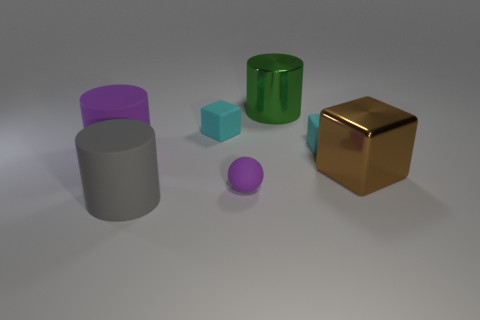Is there anything else that has the same shape as the small purple object?
Make the answer very short. No. The cyan object that is to the right of the tiny cyan rubber object that is on the left side of the purple ball is what shape?
Your response must be concise. Cube. There is a big block that is the same material as the green thing; what is its color?
Give a very brief answer. Brown. Is the large metal block the same color as the matte sphere?
Make the answer very short. No. The gray matte thing that is the same size as the brown object is what shape?
Ensure brevity in your answer.  Cylinder. What is the size of the purple rubber sphere?
Offer a very short reply. Small. Is the size of the cyan block on the left side of the purple ball the same as the cylinder left of the large gray matte cylinder?
Make the answer very short. No. There is a metal thing that is on the right side of the matte thing right of the matte sphere; what is its color?
Your answer should be very brief. Brown. What is the material of the cube that is the same size as the gray rubber cylinder?
Provide a succinct answer. Metal. What number of metallic objects are either large purple things or purple things?
Your answer should be compact. 0. 